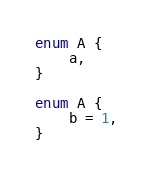Convert code to text. <code><loc_0><loc_0><loc_500><loc_500><_TypeScript_>enum A {
	a,
}

enum A {
	b = 1,
}
</code> 